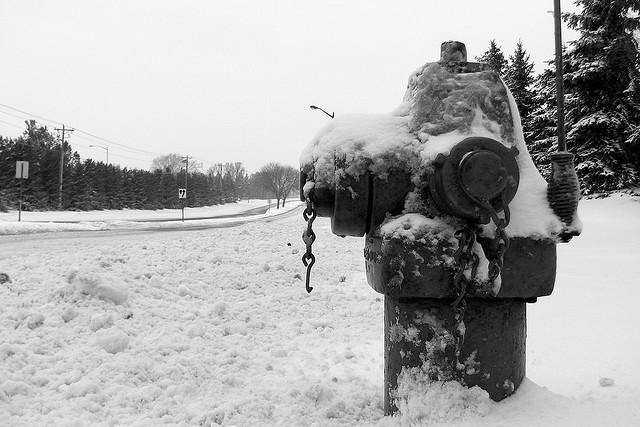What is the ground covered with?
Short answer required. Snow. How many telephone poles are there?
Be succinct. 2. How many street signs are there?
Be succinct. 2. 